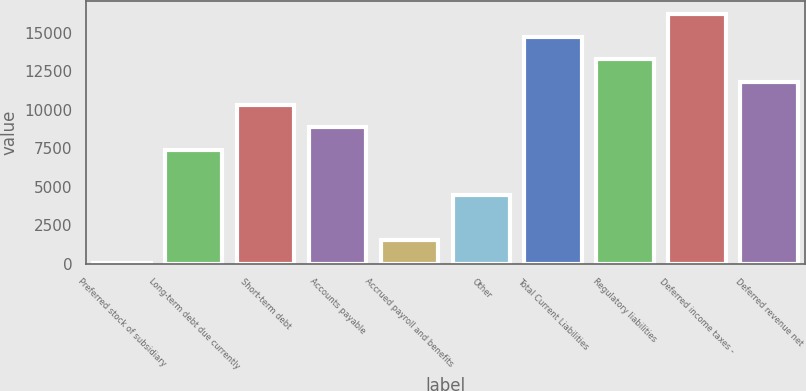<chart> <loc_0><loc_0><loc_500><loc_500><bar_chart><fcel>Preferred stock of subsidiary<fcel>Long-term debt due currently<fcel>Short-term debt<fcel>Accounts payable<fcel>Accrued payroll and benefits<fcel>Other<fcel>Total Current Liabilities<fcel>Regulatory liabilities<fcel>Deferred income taxes -<fcel>Deferred revenue net<nl><fcel>30.4<fcel>7399.9<fcel>10347.7<fcel>8873.8<fcel>1504.3<fcel>4452.1<fcel>14769.4<fcel>13295.5<fcel>16243.3<fcel>11821.6<nl></chart> 